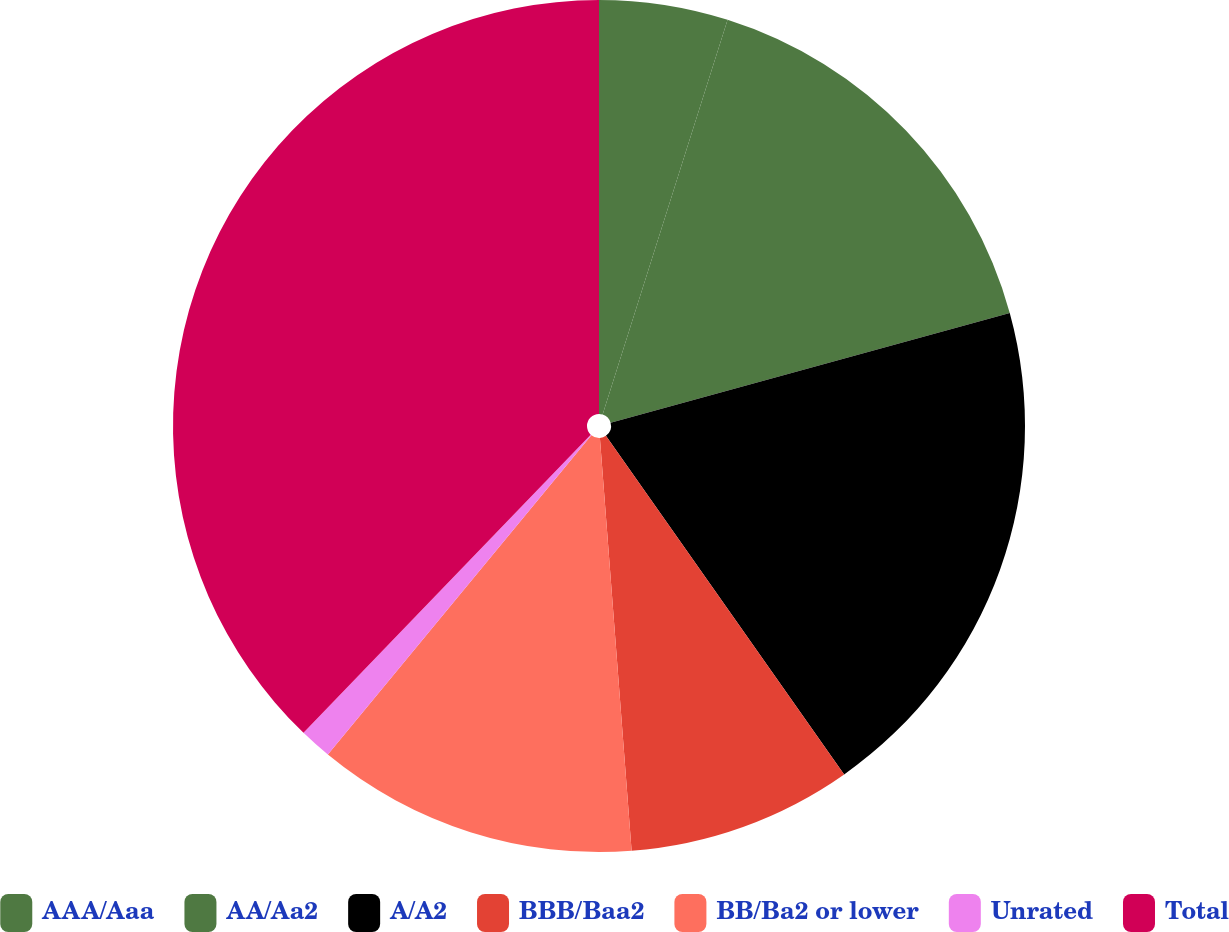<chart> <loc_0><loc_0><loc_500><loc_500><pie_chart><fcel>AAA/Aaa<fcel>AA/Aa2<fcel>A/A2<fcel>BBB/Baa2<fcel>BB/Ba2 or lower<fcel>Unrated<fcel>Total<nl><fcel>4.88%<fcel>15.85%<fcel>19.51%<fcel>8.54%<fcel>12.2%<fcel>1.22%<fcel>37.8%<nl></chart> 